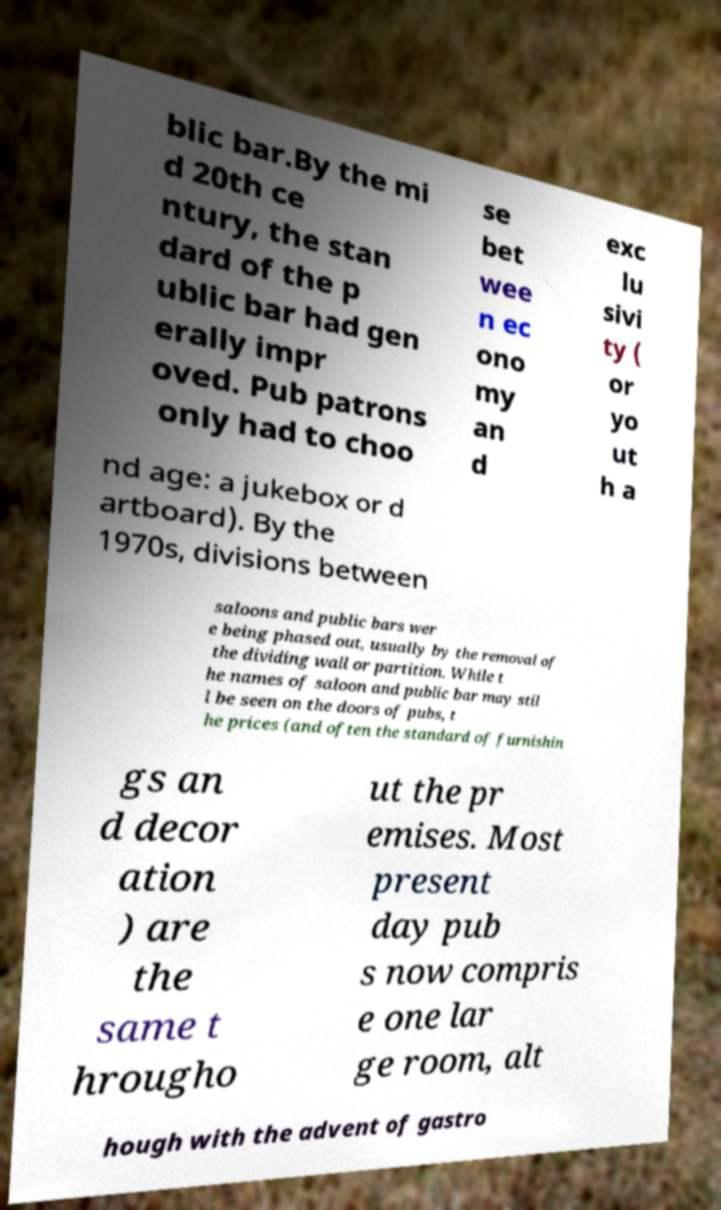What messages or text are displayed in this image? I need them in a readable, typed format. blic bar.By the mi d 20th ce ntury, the stan dard of the p ublic bar had gen erally impr oved. Pub patrons only had to choo se bet wee n ec ono my an d exc lu sivi ty ( or yo ut h a nd age: a jukebox or d artboard). By the 1970s, divisions between saloons and public bars wer e being phased out, usually by the removal of the dividing wall or partition. While t he names of saloon and public bar may stil l be seen on the doors of pubs, t he prices (and often the standard of furnishin gs an d decor ation ) are the same t hrougho ut the pr emises. Most present day pub s now compris e one lar ge room, alt hough with the advent of gastro 